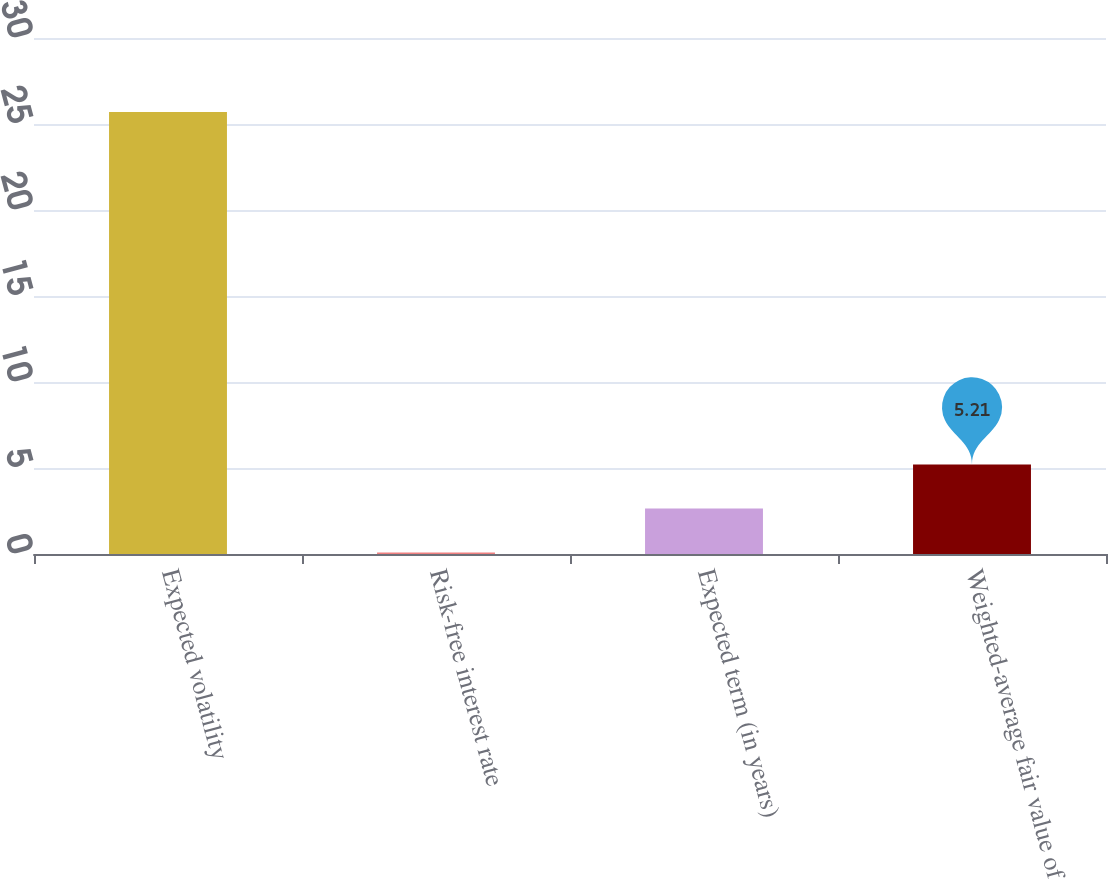Convert chart to OTSL. <chart><loc_0><loc_0><loc_500><loc_500><bar_chart><fcel>Expected volatility<fcel>Risk-free interest rate<fcel>Expected term (in years)<fcel>Weighted-average fair value of<nl><fcel>25.7<fcel>0.09<fcel>2.65<fcel>5.21<nl></chart> 